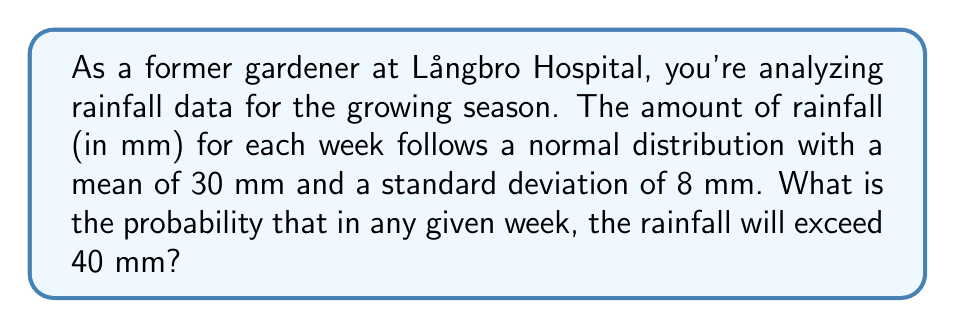Show me your answer to this math problem. Let's approach this step-by-step:

1) We're dealing with a normal distribution where:
   $\mu = 30$ mm (mean)
   $\sigma = 8$ mm (standard deviation)

2) We want to find $P(X > 40)$, where $X$ is the amount of rainfall in a week.

3) To solve this, we need to standardize the normal distribution by calculating the z-score:

   $z = \frac{x - \mu}{\sigma} = \frac{40 - 30}{8} = \frac{10}{8} = 1.25$

4) Now, we need to find $P(Z > 1.25)$ in the standard normal distribution.

5) Using a standard normal table or calculator, we can find that:
   $P(Z < 1.25) \approx 0.8944$

6) Since we want the probability of exceeding 40 mm, we need:
   $P(Z > 1.25) = 1 - P(Z < 1.25) = 1 - 0.8944 = 0.1056$

Therefore, the probability that the rainfall will exceed 40 mm in any given week is approximately 0.1056 or 10.56%.
Answer: 0.1056 